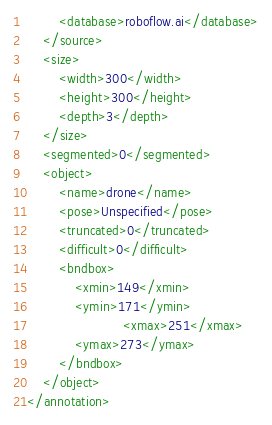Convert code to text. <code><loc_0><loc_0><loc_500><loc_500><_XML_>		<database>roboflow.ai</database>
	</source>
	<size>
		<width>300</width>
		<height>300</height>
		<depth>3</depth>
	</size>
	<segmented>0</segmented>
	<object>
		<name>drone</name>
		<pose>Unspecified</pose>
		<truncated>0</truncated>
		<difficult>0</difficult>
		<bndbox>
			<xmin>149</xmin>
			<ymin>171</ymin>
                        <xmax>251</xmax>
			<ymax>273</ymax>
		</bndbox>
	</object>
</annotation>
</code> 